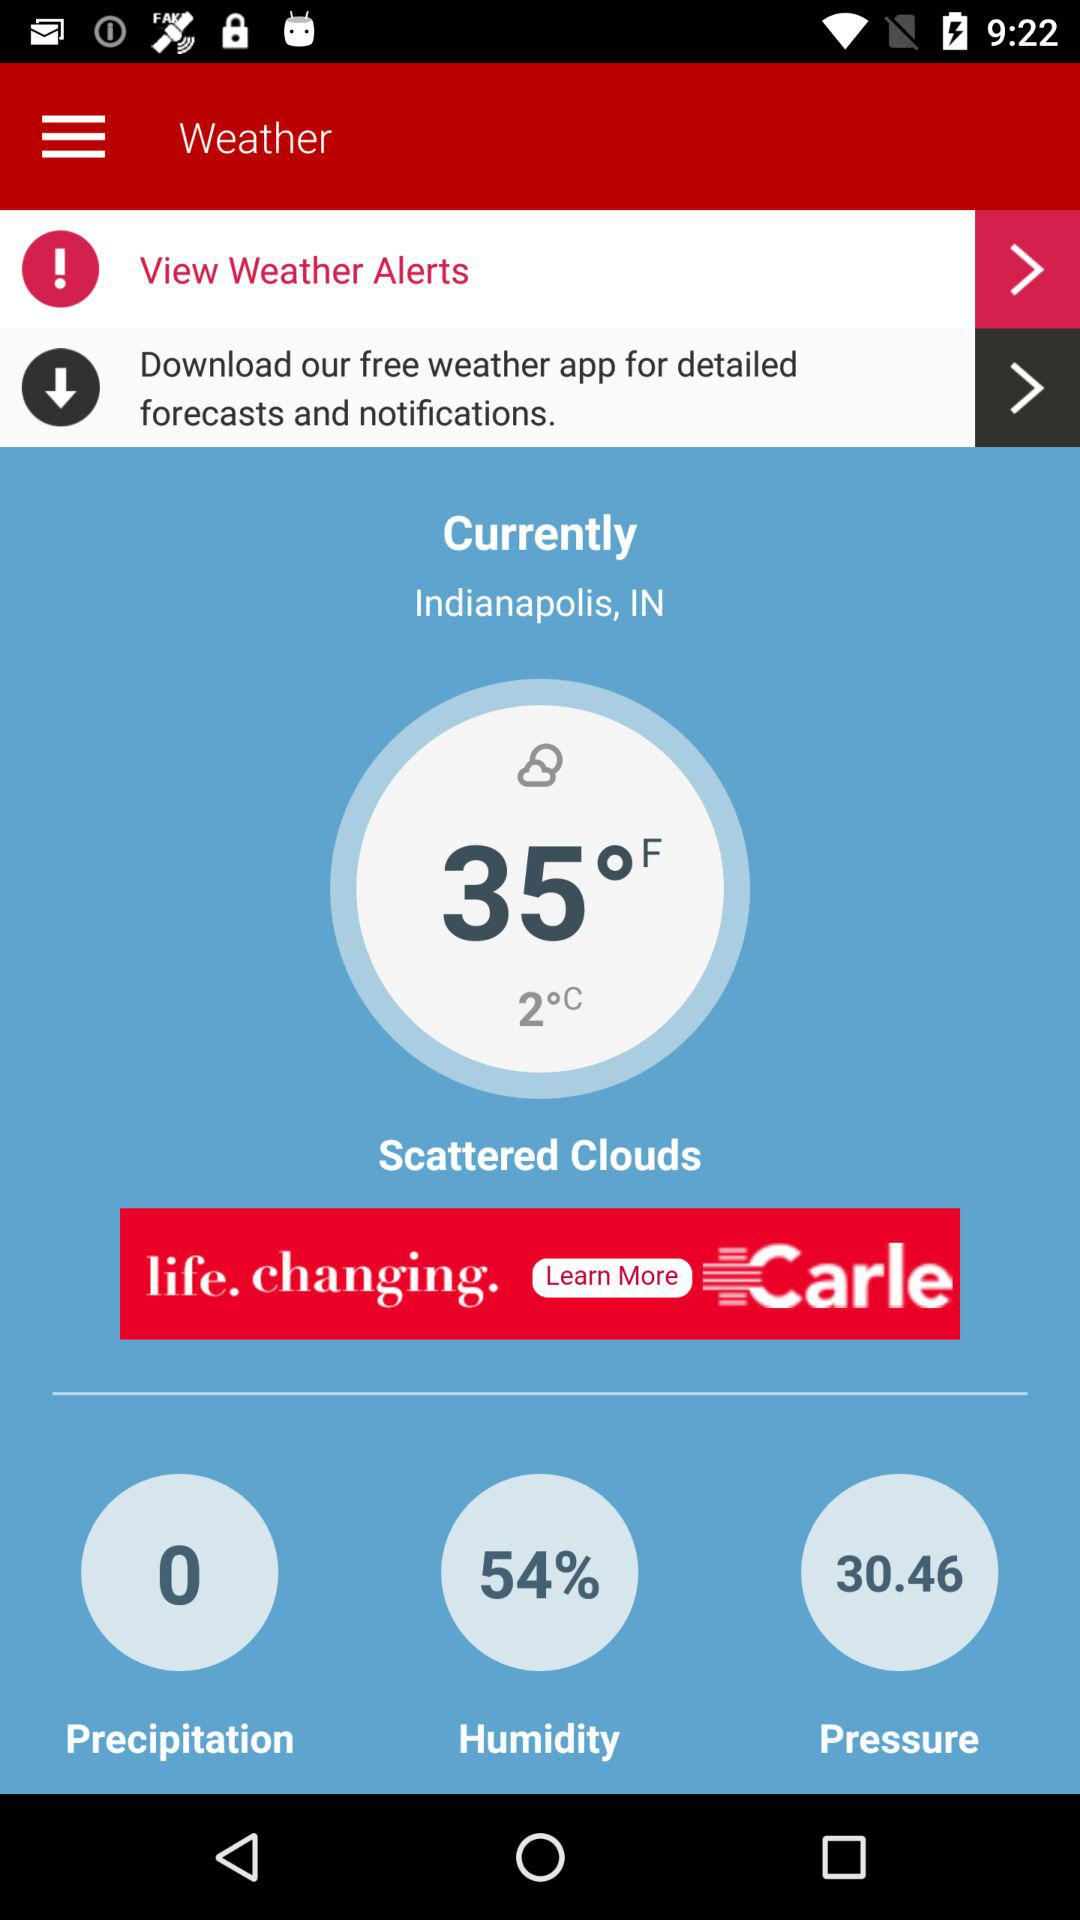What is the percentage of humidity?
Answer the question using a single word or phrase. 54% 